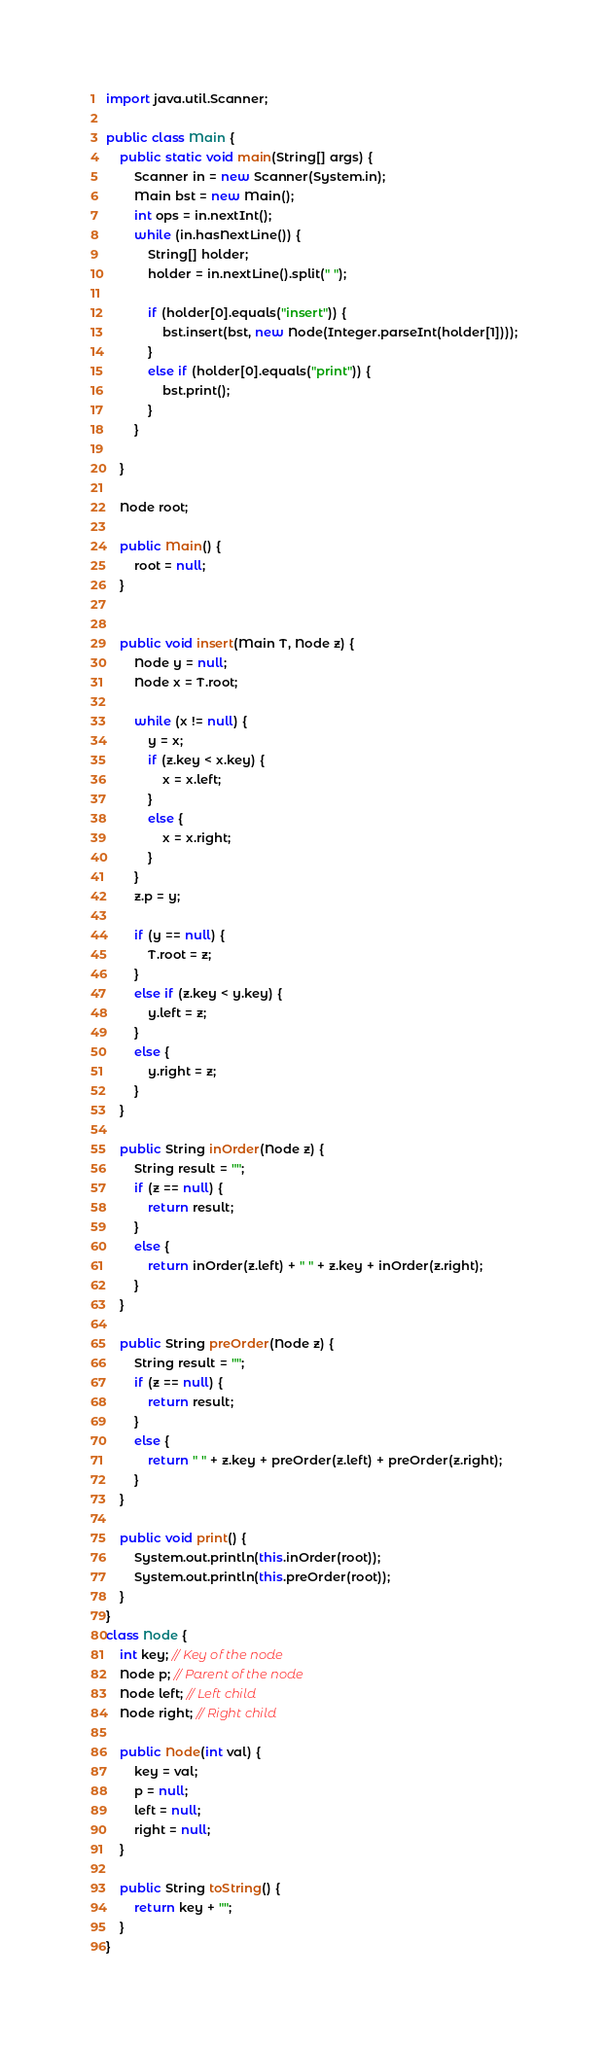Convert code to text. <code><loc_0><loc_0><loc_500><loc_500><_Java_>
import java.util.Scanner;

public class Main {
	public static void main(String[] args) {
		Scanner in = new Scanner(System.in);
		Main bst = new Main();
		int ops = in.nextInt();
		while (in.hasNextLine()) {
			String[] holder;
			holder = in.nextLine().split(" ");
			
			if (holder[0].equals("insert")) {
				bst.insert(bst, new Node(Integer.parseInt(holder[1])));
			}
			else if (holder[0].equals("print")) {
				bst.print();
			}
		}
		
	}
	
	Node root;
	
	public Main() {
		root = null;
	}
	
	
	public void insert(Main T, Node z) {
		Node y = null;
		Node x = T.root;
		
		while (x != null) {
			y = x;
			if (z.key < x.key) {
				x = x.left;
			}
			else {
				x = x.right;
			}
		}
		z.p = y;
		
		if (y == null) {
			T.root = z;
		}
		else if (z.key < y.key) {
			y.left = z;
		}
		else {
			y.right = z;
		}
	}
	
	public String inOrder(Node z) {
		String result = "";
		if (z == null) {
			return result;
		}
		else {
			return inOrder(z.left) + " " + z.key + inOrder(z.right); 
		}
	}
	
	public String preOrder(Node z) {
		String result = "";
		if (z == null) {
			return result;
		}
		else {
			return " " + z.key + preOrder(z.left) + preOrder(z.right); 
		}
	}
	
	public void print() {
		System.out.println(this.inOrder(root));
		System.out.println(this.preOrder(root));
	}
}
class Node {
	int key; // Key of the node
	Node p; // Parent of the node
	Node left; // Left child
	Node right; // Right child
	
	public Node(int val) {
		key = val;
		p = null;
		left = null;
		right = null;
	}
	
	public String toString() {
		return key + "";
	}
}


</code> 